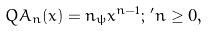Convert formula to latex. <formula><loc_0><loc_0><loc_500><loc_500>Q A _ { n } ( x ) = n _ { \psi } x ^ { n - 1 } ; \, ^ { \prime } n \geq 0 ,</formula> 